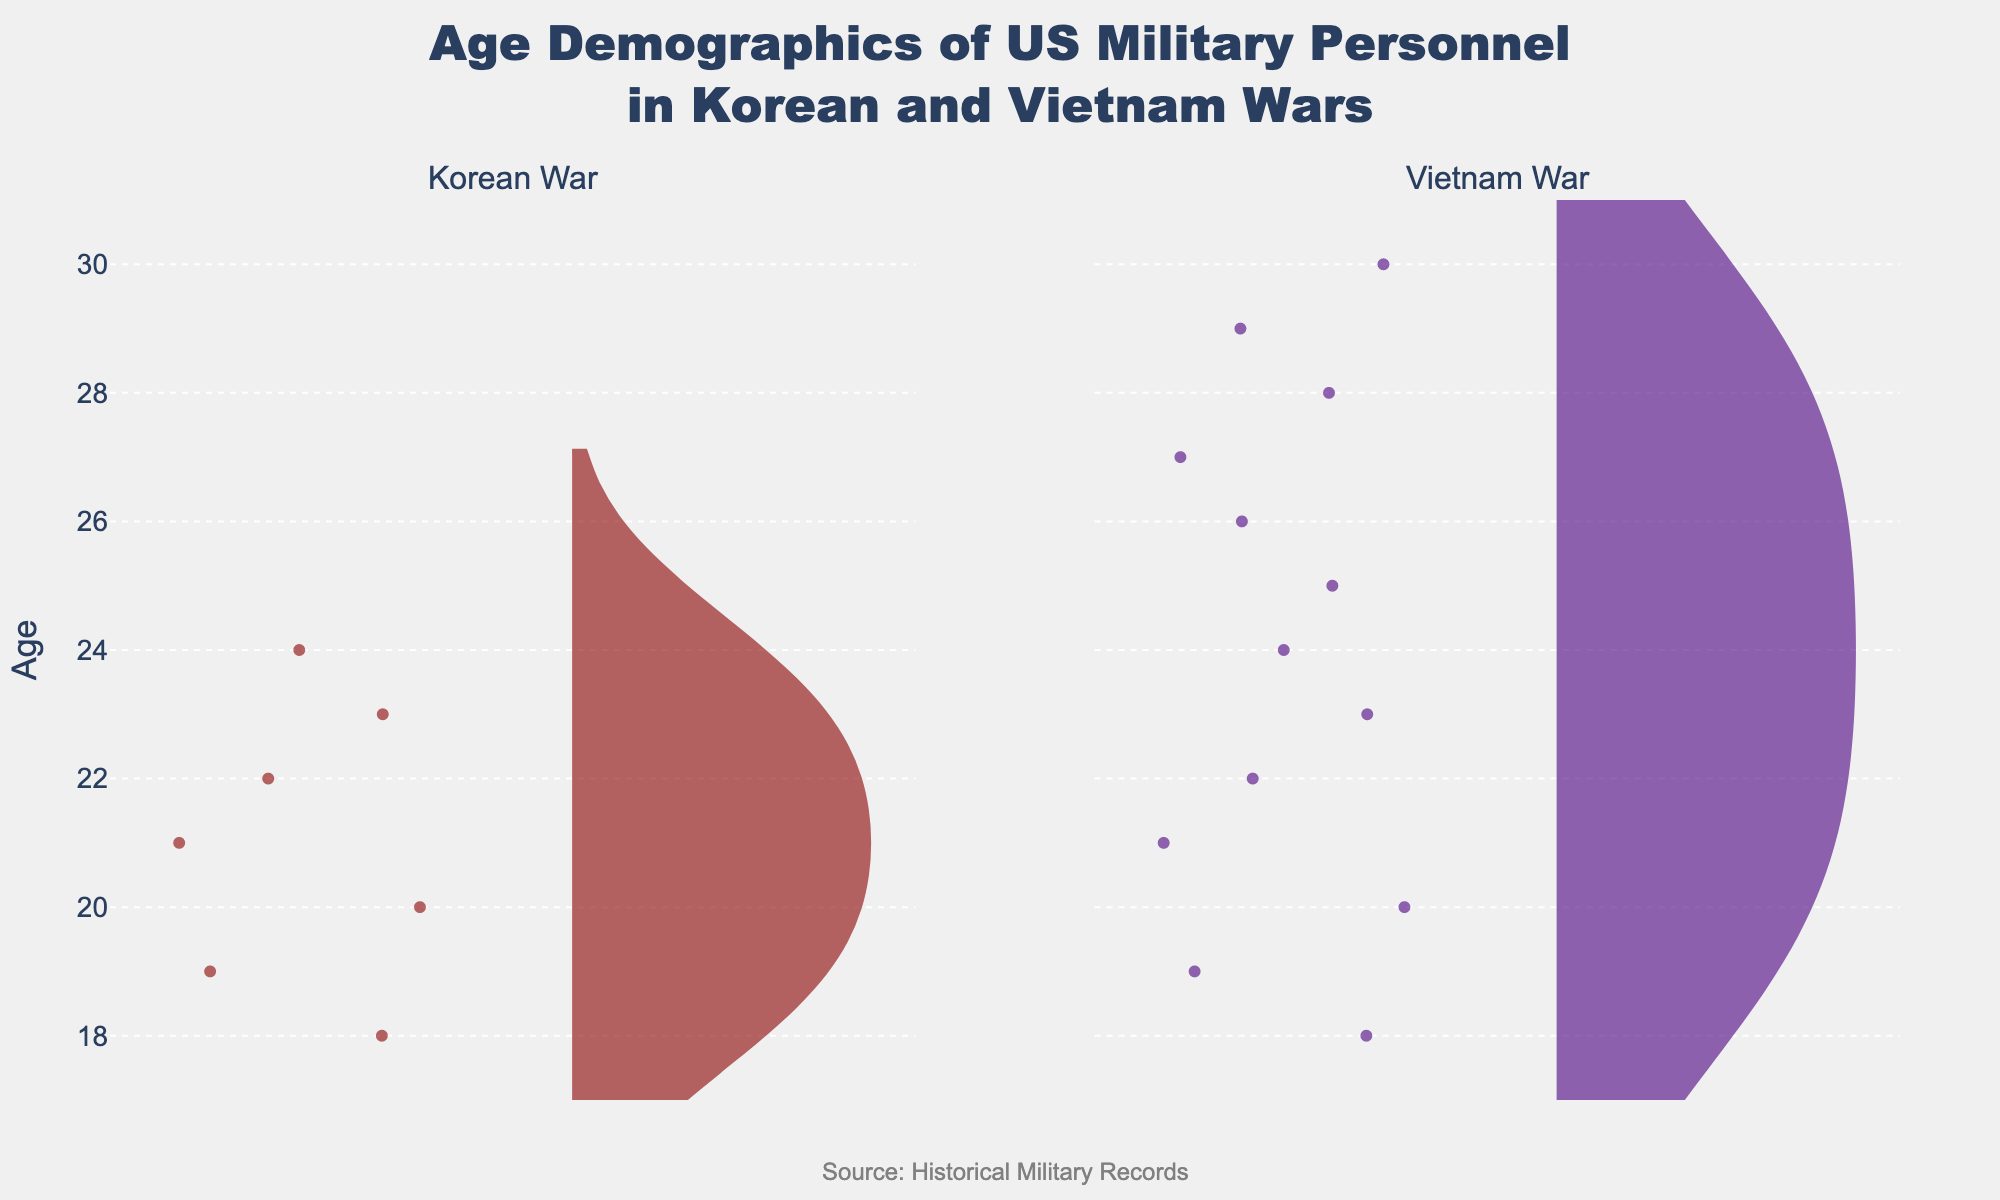What are the age ranges for US military personnel involved in the Korean War and the Vietnam War? The figure shows violin plots for both wars. The age range for the Korean War is shown from 18 to 24, and for the Vietnam War, it ranges from 18 to 30.
Answer: 18-24 for Korean War, 18-30 for Vietnam War What is the median age of US military personnel in the Korean War? The median is represented by the mean line visible in the violin plot, which splits the plot into two equal halves. For the Korean War, this median line is around age 21.
Answer: 21 Which war had a broader age distribution among US military personnel? The width and spread of the violin plots indicate the distribution. The Vietnam War violin plot extends from age 18 to 30, whereas the Korean War extends from 18 to 24, suggesting a broader age distribution for the Vietnam War.
Answer: Vietnam War Which war shows a more diverse age demographic based on the plot? The diversity can be interpreted by the range and spread of the age data points. The Vietnam War shows a broader range and more data points spread across different ages, indicating more diversity.
Answer: Vietnam War How many age groups were involved in the Korean War according to the plot? The violin plot for the Korean War shows distinct points for each age group. Counting these distinct data points gives 7 age groups (18 through 24).
Answer: 7 What is the oldest age recorded for US military personnel in the Vietnam War in this dataset? The upper end of the violin plot for the Vietnam War extends to age 30, indicating that 30 is the oldest age recorded.
Answer: 30 Does the median age of US military personnel in the Vietnam War range higher than that of the Korean War? Comparing the mean lines, the median age for the Vietnam War is somewhat above 22, which is higher than the median age of 21 for the Korean War.
Answer: Yes Is there an age demographic that is absent in the Korean War but present in the Vietnam War? Observing the violin plots, ages from 25 to 30 are present in the Vietnam War but absent in the Korean War.
Answer: Yes, ages 25-30 What is the most common age of US military personnel in both wars? The peak or the widest section of each violin plot represents the most common age. For the Korean War, it’s around 21, and for the Vietnam War, it appears around 19-21, with possibly 20 being the most frequent.
Answer: 21 for Korean War, 20 for Vietnam War 